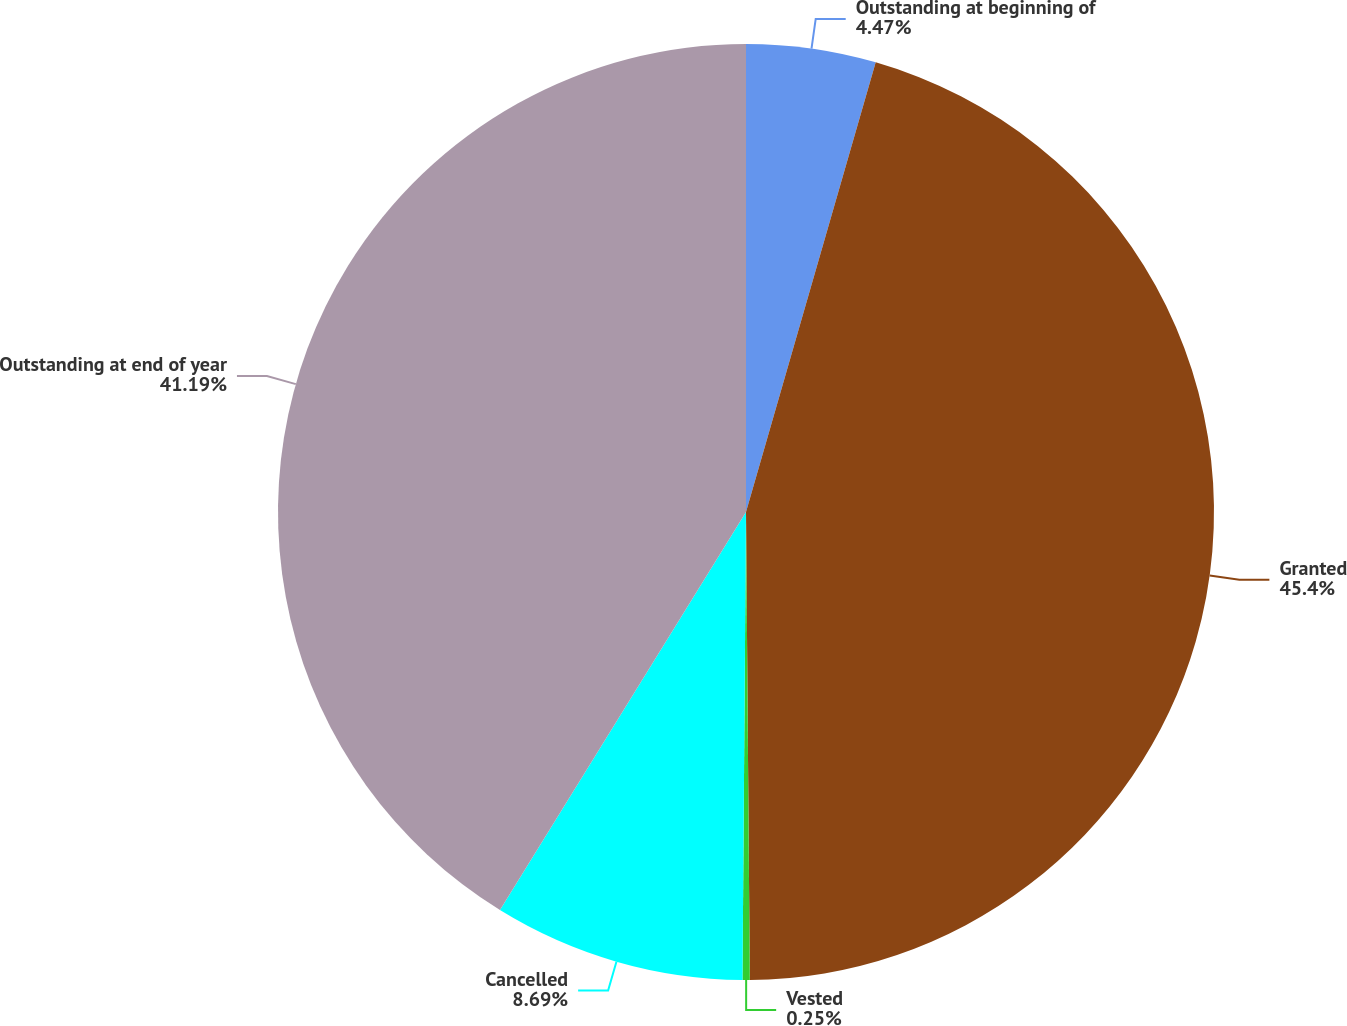<chart> <loc_0><loc_0><loc_500><loc_500><pie_chart><fcel>Outstanding at beginning of<fcel>Granted<fcel>Vested<fcel>Cancelled<fcel>Outstanding at end of year<nl><fcel>4.47%<fcel>45.4%<fcel>0.25%<fcel>8.69%<fcel>41.19%<nl></chart> 